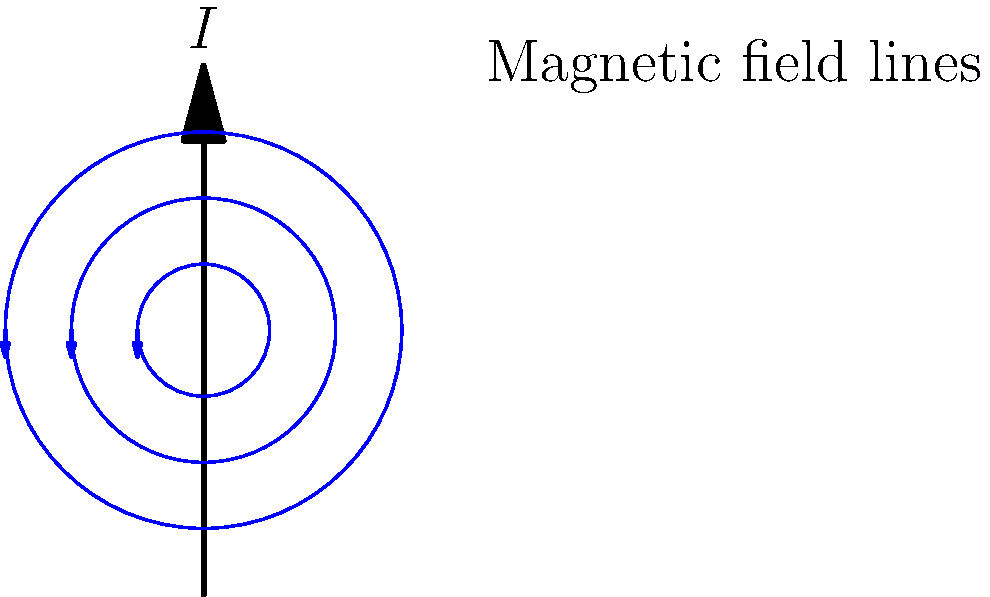In the context of natural language processing for document preservation, consider a current-carrying wire as shown in the diagram. The current $I$ flows upward. How would you describe the pattern of the magnetic field lines around the wire, and what fundamental principle of electromagnetism does this illustrate? To answer this question, let's break it down step-by-step:

1. Observation of the diagram:
   - The wire is represented by a vertical line with an upward arrow, indicating current flow in the upward direction.
   - Circular lines surround the wire, representing the magnetic field lines.
   - Small arrows on these circular lines indicate the direction of the magnetic field.

2. Pattern of magnetic field lines:
   - The magnetic field lines form concentric circles around the wire.
   - These circles lie in planes perpendicular to the wire.
   - The field lines are more densely packed near the wire and become less dense as we move away from it.

3. Direction of the magnetic field:
   - The direction of the magnetic field follows the right-hand rule for a straight current-carrying wire.
   - With the thumb pointing in the direction of the current (upward in this case), the fingers curl around the wire in the direction of the magnetic field.
   - In the diagram, this is represented by the counterclockwise direction of the arrows on the field lines.

4. Fundamental principle illustrated:
   - This pattern illustrates Ampère's Law, one of Maxwell's equations in electromagnetism.
   - Ampère's Law states that a current creates a magnetic field around it.
   - The strength of this magnetic field is proportional to the current and inversely proportional to the distance from the wire.

5. Relevance to NLP and document preservation:
   - Understanding electromagnetic principles is crucial for preserving digital documents, as they are often stored on magnetic media.
   - In NLP tasks related to document preservation, recognizing and correctly interpreting diagrams like this one could be important for processing scientific or technical documents.
Answer: Concentric circular magnetic field lines around the wire, following the right-hand rule, illustrating Ampère's Law. 